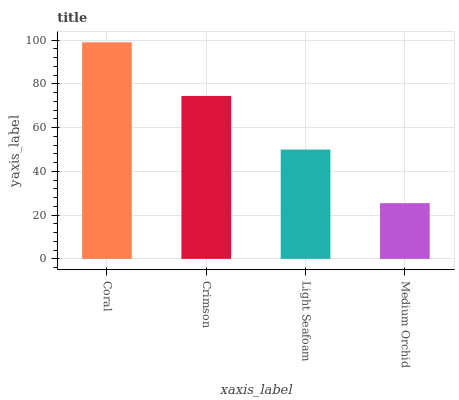Is Medium Orchid the minimum?
Answer yes or no. Yes. Is Coral the maximum?
Answer yes or no. Yes. Is Crimson the minimum?
Answer yes or no. No. Is Crimson the maximum?
Answer yes or no. No. Is Coral greater than Crimson?
Answer yes or no. Yes. Is Crimson less than Coral?
Answer yes or no. Yes. Is Crimson greater than Coral?
Answer yes or no. No. Is Coral less than Crimson?
Answer yes or no. No. Is Crimson the high median?
Answer yes or no. Yes. Is Light Seafoam the low median?
Answer yes or no. Yes. Is Medium Orchid the high median?
Answer yes or no. No. Is Crimson the low median?
Answer yes or no. No. 